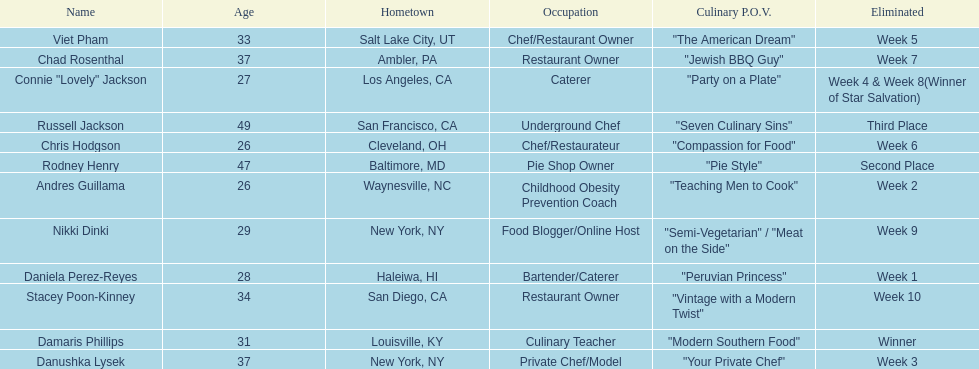Which competitor only lasted two weeks? Andres Guillama. 